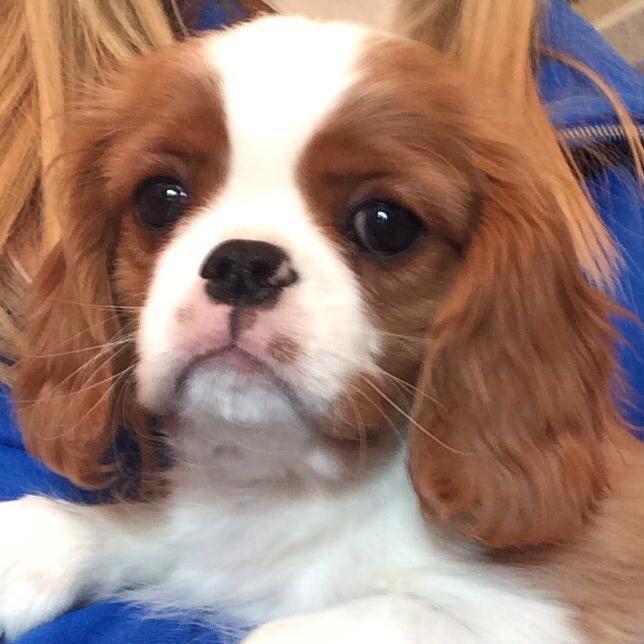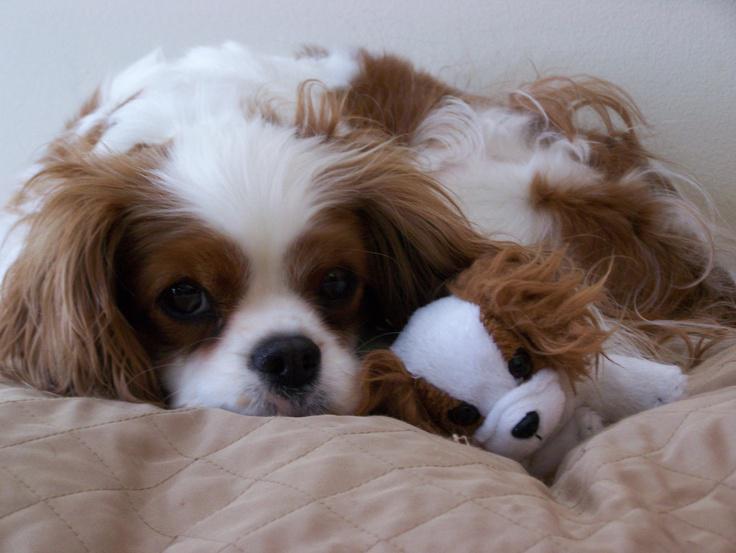The first image is the image on the left, the second image is the image on the right. Assess this claim about the two images: "Each image contains one 'real' live spaniel with dry orange-and-white fur, and one dog is posed on folds of pale fabric.". Correct or not? Answer yes or no. Yes. 